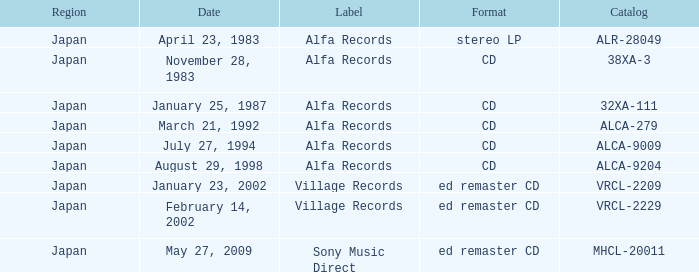Which label is dated February 14, 2002? Village Records. 